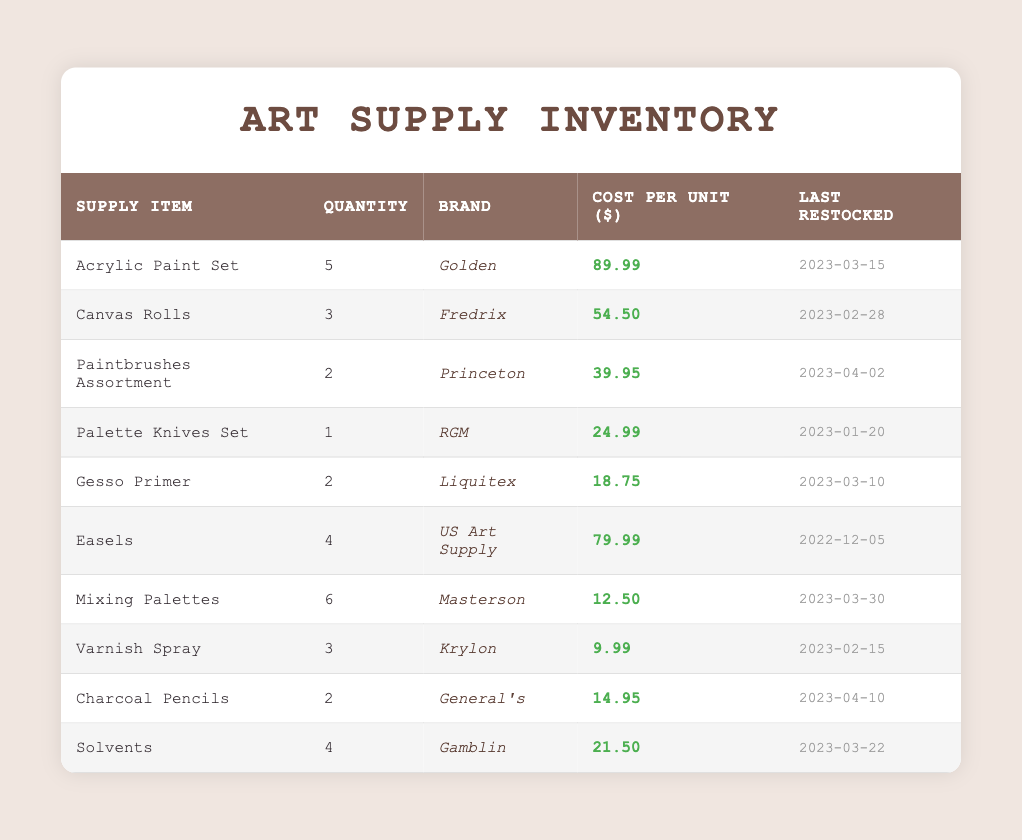What is the total quantity of Paintbrushes Assortment in the inventory? The table shows that there are 2 units of Paintbrushes Assortment listed under the Quantity column.
Answer: 2 Which supply item has the highest cost per unit? By reviewing the Cost per Unit column, the highest value is 89.99 for the Acrylic Paint Set.
Answer: Acrylic Paint Set Is the Varnish Spray restocked more recently than the Palette Knives Set? Varnish Spray's last restocked date is 2023-02-15, and Palette Knives Set is 2023-01-20. Since 2023-02-15 is later than 2023-01-20, Varnish Spray was restocked more recently.
Answer: Yes What is the total cost of all the Canvas Rolls in the inventory? The table shows 3 units of Canvas Rolls at a cost of 54.50 each. To find the total cost, multiply the quantity by the cost per unit: 3 * 54.50 = 163.50.
Answer: 163.50 How many more units of Mixing Palettes are there than Palette Knives Set? There are 6 units of Mixing Palettes compared to 1 unit of Palette Knives Set. The difference is 6 - 1 = 5.
Answer: 5 Is there an item in the inventory with a quantity of 0 units? The table shows all items have a listed quantity of at least 1. Therefore, there are no items with 0 units.
Answer: No What is the average cost per unit of all the items in the inventory? To find the average, sum all the individual costs: (89.99 + 54.50 + 39.95 + 24.99 + 18.75 + 79.99 + 12.50 + 9.99 + 14.95 + 21.50) = 354.16. There are 10 items, so divide by 10: 354.16 / 10 = 35.416.
Answer: 35.416 Which brand has the fewest items in the inventory? The least quantity in the inventory is for Palette Knives Set with 1 unit, indicating it is the item with the fewest units.
Answer: RGM 